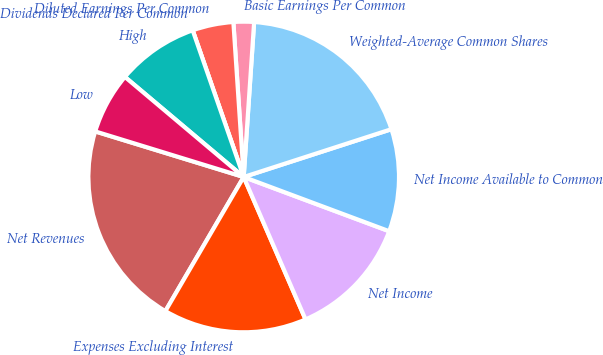Convert chart to OTSL. <chart><loc_0><loc_0><loc_500><loc_500><pie_chart><fcel>Net Revenues<fcel>Expenses Excluding Interest<fcel>Net Income<fcel>Net Income Available to Common<fcel>Weighted-Average Common Shares<fcel>Basic Earnings Per Common<fcel>Diluted Earnings Per Common<fcel>Dividends Declared Per Common<fcel>High<fcel>Low<nl><fcel>21.33%<fcel>14.93%<fcel>12.8%<fcel>10.66%<fcel>18.95%<fcel>2.13%<fcel>4.27%<fcel>0.0%<fcel>8.53%<fcel>6.4%<nl></chart> 